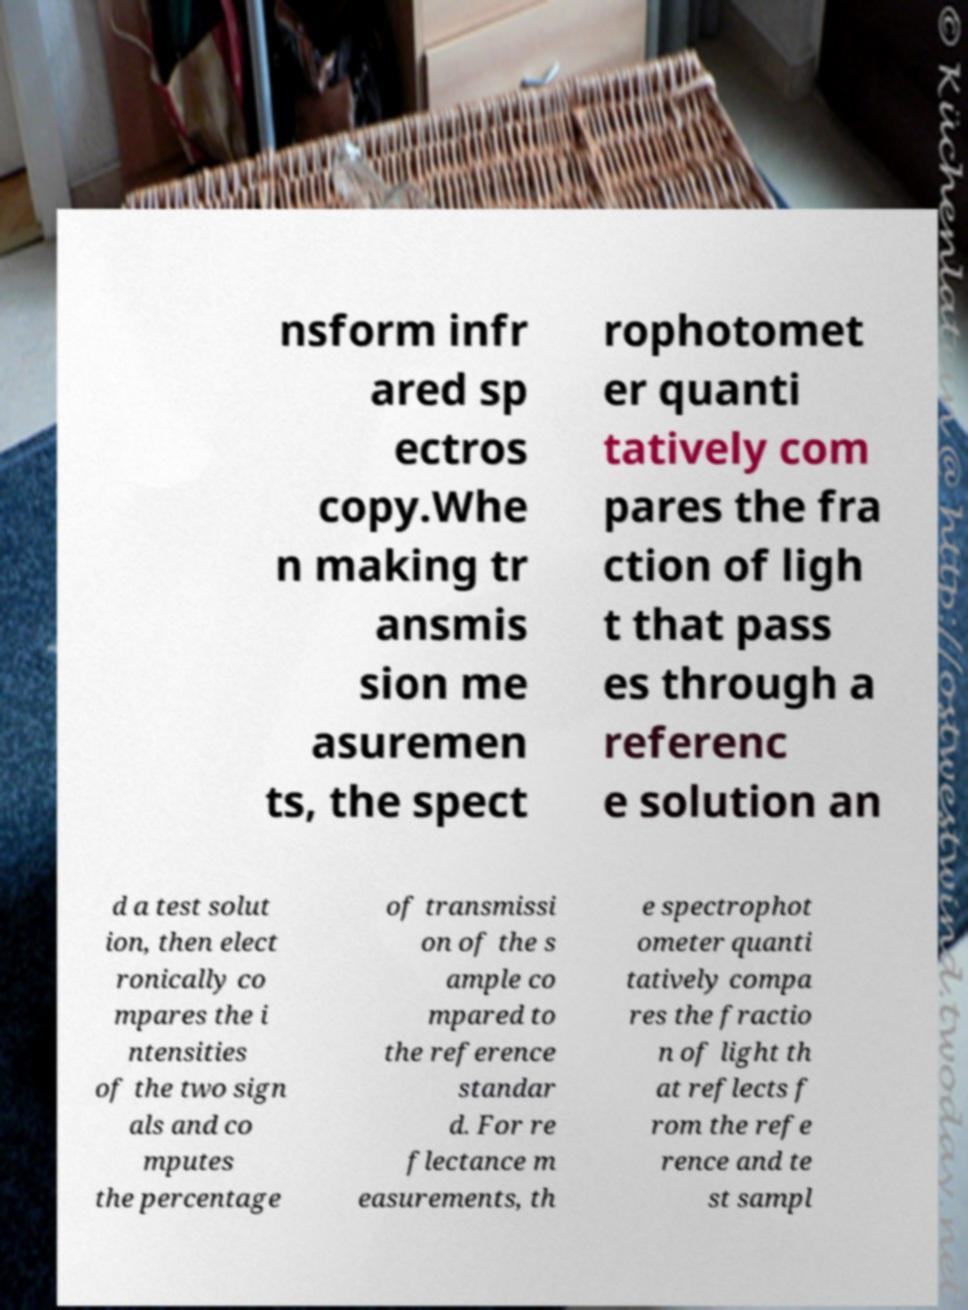Could you assist in decoding the text presented in this image and type it out clearly? nsform infr ared sp ectros copy.Whe n making tr ansmis sion me asuremen ts, the spect rophotomet er quanti tatively com pares the fra ction of ligh t that pass es through a referenc e solution an d a test solut ion, then elect ronically co mpares the i ntensities of the two sign als and co mputes the percentage of transmissi on of the s ample co mpared to the reference standar d. For re flectance m easurements, th e spectrophot ometer quanti tatively compa res the fractio n of light th at reflects f rom the refe rence and te st sampl 